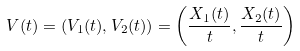<formula> <loc_0><loc_0><loc_500><loc_500>\ V ( t ) = ( V _ { 1 } ( t ) , V _ { 2 } ( t ) ) = \left ( \frac { X _ { 1 } ( t ) } { t } , \frac { X _ { 2 } ( t ) } { t } \right )</formula> 